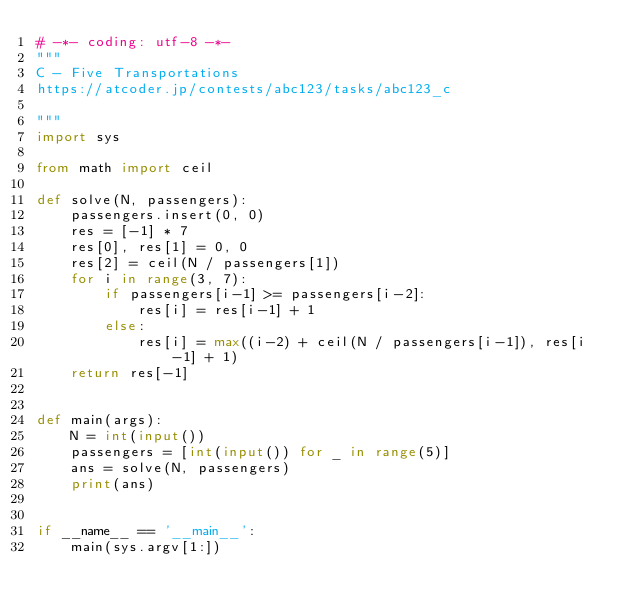Convert code to text. <code><loc_0><loc_0><loc_500><loc_500><_Python_># -*- coding: utf-8 -*-
"""
C - Five Transportations
https://atcoder.jp/contests/abc123/tasks/abc123_c

"""
import sys

from math import ceil

def solve(N, passengers):
    passengers.insert(0, 0)
    res = [-1] * 7
    res[0], res[1] = 0, 0
    res[2] = ceil(N / passengers[1])
    for i in range(3, 7):
        if passengers[i-1] >= passengers[i-2]:
            res[i] = res[i-1] + 1
        else:
            res[i] = max((i-2) + ceil(N / passengers[i-1]), res[i-1] + 1)
    return res[-1]


def main(args):
    N = int(input())
    passengers = [int(input()) for _ in range(5)]
    ans = solve(N, passengers)
    print(ans)


if __name__ == '__main__':
    main(sys.argv[1:])
</code> 